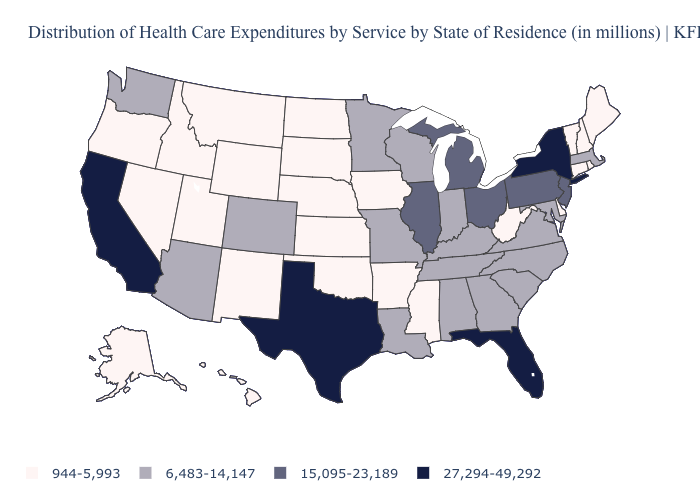Does Alabama have a higher value than Alaska?
Write a very short answer. Yes. What is the lowest value in the USA?
Give a very brief answer. 944-5,993. Name the states that have a value in the range 6,483-14,147?
Be succinct. Alabama, Arizona, Colorado, Georgia, Indiana, Kentucky, Louisiana, Maryland, Massachusetts, Minnesota, Missouri, North Carolina, South Carolina, Tennessee, Virginia, Washington, Wisconsin. What is the value of Colorado?
Write a very short answer. 6,483-14,147. What is the highest value in the USA?
Quick response, please. 27,294-49,292. Does Washington have the lowest value in the West?
Quick response, please. No. Does Nebraska have the lowest value in the MidWest?
Short answer required. Yes. What is the value of Tennessee?
Give a very brief answer. 6,483-14,147. What is the value of Louisiana?
Write a very short answer. 6,483-14,147. Among the states that border Kansas , which have the highest value?
Quick response, please. Colorado, Missouri. Which states have the lowest value in the South?
Concise answer only. Arkansas, Delaware, Mississippi, Oklahoma, West Virginia. What is the lowest value in the West?
Quick response, please. 944-5,993. Does Utah have the same value as Idaho?
Be succinct. Yes. Name the states that have a value in the range 27,294-49,292?
Write a very short answer. California, Florida, New York, Texas. What is the lowest value in the USA?
Give a very brief answer. 944-5,993. 